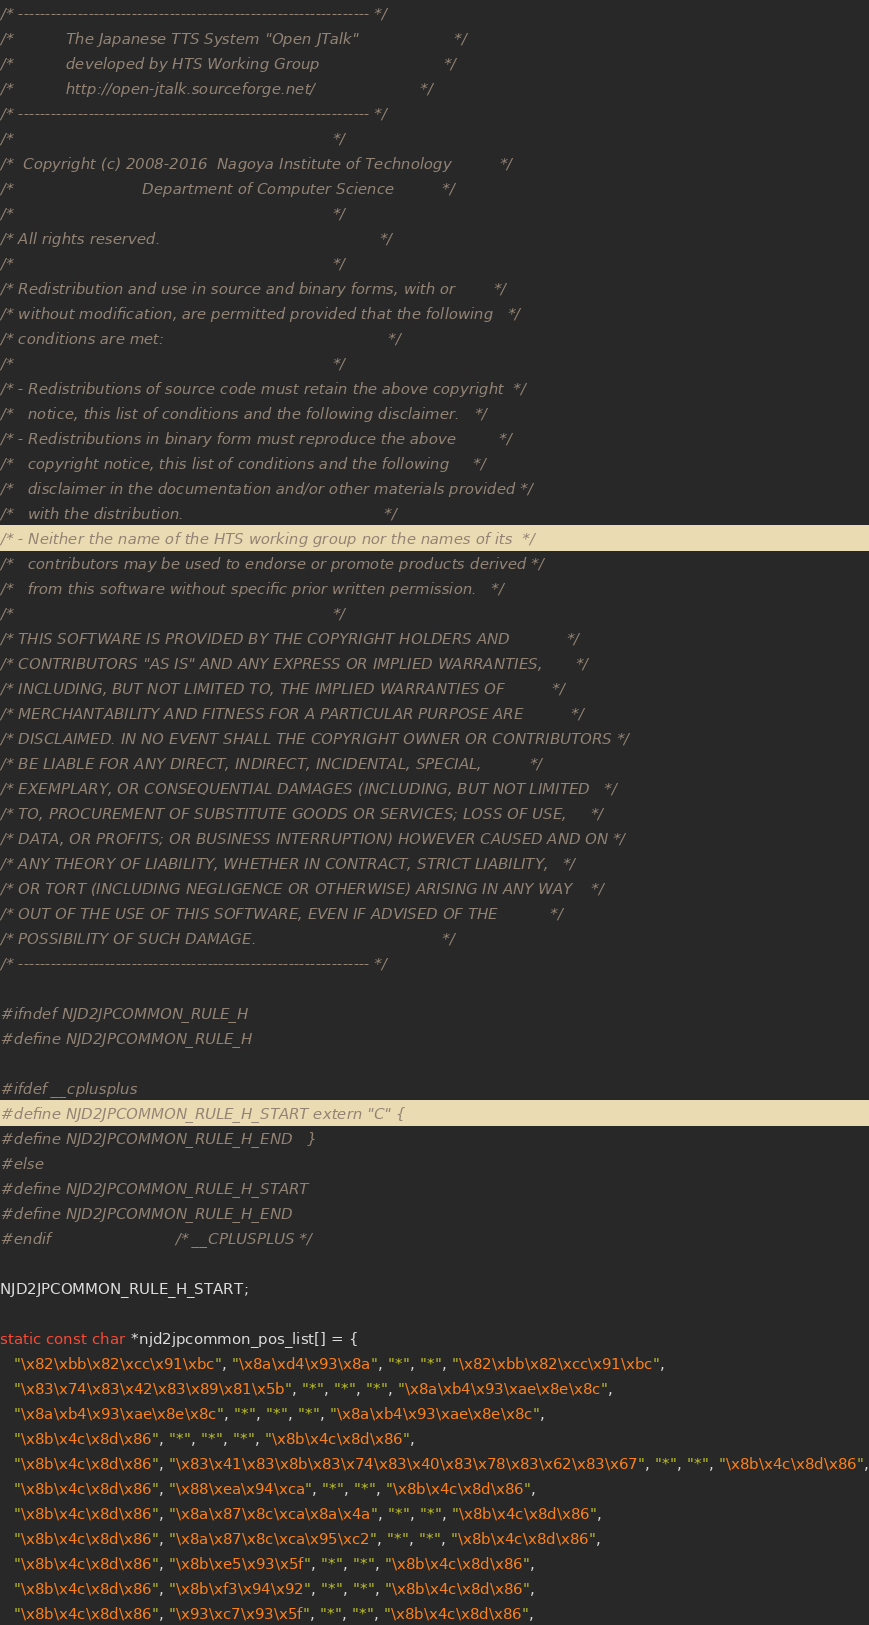Convert code to text. <code><loc_0><loc_0><loc_500><loc_500><_C_>/* ----------------------------------------------------------------- */
/*           The Japanese TTS System "Open JTalk"                    */
/*           developed by HTS Working Group                          */
/*           http://open-jtalk.sourceforge.net/                      */
/* ----------------------------------------------------------------- */
/*                                                                   */
/*  Copyright (c) 2008-2016  Nagoya Institute of Technology          */
/*                           Department of Computer Science          */
/*                                                                   */
/* All rights reserved.                                              */
/*                                                                   */
/* Redistribution and use in source and binary forms, with or        */
/* without modification, are permitted provided that the following   */
/* conditions are met:                                               */
/*                                                                   */
/* - Redistributions of source code must retain the above copyright  */
/*   notice, this list of conditions and the following disclaimer.   */
/* - Redistributions in binary form must reproduce the above         */
/*   copyright notice, this list of conditions and the following     */
/*   disclaimer in the documentation and/or other materials provided */
/*   with the distribution.                                          */
/* - Neither the name of the HTS working group nor the names of its  */
/*   contributors may be used to endorse or promote products derived */
/*   from this software without specific prior written permission.   */
/*                                                                   */
/* THIS SOFTWARE IS PROVIDED BY THE COPYRIGHT HOLDERS AND            */
/* CONTRIBUTORS "AS IS" AND ANY EXPRESS OR IMPLIED WARRANTIES,       */
/* INCLUDING, BUT NOT LIMITED TO, THE IMPLIED WARRANTIES OF          */
/* MERCHANTABILITY AND FITNESS FOR A PARTICULAR PURPOSE ARE          */
/* DISCLAIMED. IN NO EVENT SHALL THE COPYRIGHT OWNER OR CONTRIBUTORS */
/* BE LIABLE FOR ANY DIRECT, INDIRECT, INCIDENTAL, SPECIAL,          */
/* EXEMPLARY, OR CONSEQUENTIAL DAMAGES (INCLUDING, BUT NOT LIMITED   */
/* TO, PROCUREMENT OF SUBSTITUTE GOODS OR SERVICES; LOSS OF USE,     */
/* DATA, OR PROFITS; OR BUSINESS INTERRUPTION) HOWEVER CAUSED AND ON */
/* ANY THEORY OF LIABILITY, WHETHER IN CONTRACT, STRICT LIABILITY,   */
/* OR TORT (INCLUDING NEGLIGENCE OR OTHERWISE) ARISING IN ANY WAY    */
/* OUT OF THE USE OF THIS SOFTWARE, EVEN IF ADVISED OF THE           */
/* POSSIBILITY OF SUCH DAMAGE.                                       */
/* ----------------------------------------------------------------- */

#ifndef NJD2JPCOMMON_RULE_H
#define NJD2JPCOMMON_RULE_H

#ifdef __cplusplus
#define NJD2JPCOMMON_RULE_H_START extern "C" {
#define NJD2JPCOMMON_RULE_H_END   }
#else
#define NJD2JPCOMMON_RULE_H_START
#define NJD2JPCOMMON_RULE_H_END
#endif                          /* __CPLUSPLUS */

NJD2JPCOMMON_RULE_H_START;

static const char *njd2jpcommon_pos_list[] = {
   "\x82\xbb\x82\xcc\x91\xbc", "\x8a\xd4\x93\x8a", "*", "*", "\x82\xbb\x82\xcc\x91\xbc",
   "\x83\x74\x83\x42\x83\x89\x81\x5b", "*", "*", "*", "\x8a\xb4\x93\xae\x8e\x8c",
   "\x8a\xb4\x93\xae\x8e\x8c", "*", "*", "*", "\x8a\xb4\x93\xae\x8e\x8c",
   "\x8b\x4c\x8d\x86", "*", "*", "*", "\x8b\x4c\x8d\x86",
   "\x8b\x4c\x8d\x86", "\x83\x41\x83\x8b\x83\x74\x83\x40\x83\x78\x83\x62\x83\x67", "*", "*", "\x8b\x4c\x8d\x86",
   "\x8b\x4c\x8d\x86", "\x88\xea\x94\xca", "*", "*", "\x8b\x4c\x8d\x86",
   "\x8b\x4c\x8d\x86", "\x8a\x87\x8c\xca\x8a\x4a", "*", "*", "\x8b\x4c\x8d\x86",
   "\x8b\x4c\x8d\x86", "\x8a\x87\x8c\xca\x95\xc2", "*", "*", "\x8b\x4c\x8d\x86",
   "\x8b\x4c\x8d\x86", "\x8b\xe5\x93\x5f", "*", "*", "\x8b\x4c\x8d\x86",
   "\x8b\x4c\x8d\x86", "\x8b\xf3\x94\x92", "*", "*", "\x8b\x4c\x8d\x86",
   "\x8b\x4c\x8d\x86", "\x93\xc7\x93\x5f", "*", "*", "\x8b\x4c\x8d\x86",</code> 